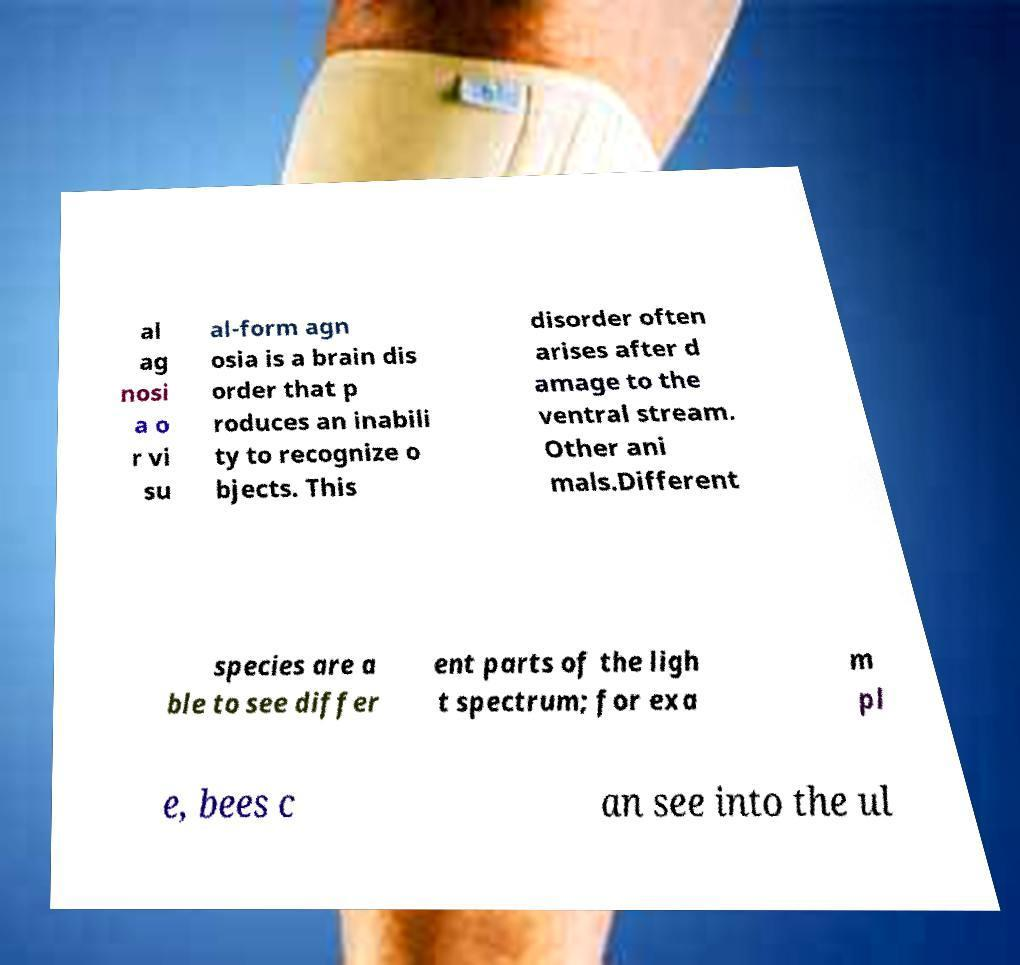Can you accurately transcribe the text from the provided image for me? al ag nosi a o r vi su al-form agn osia is a brain dis order that p roduces an inabili ty to recognize o bjects. This disorder often arises after d amage to the ventral stream. Other ani mals.Different species are a ble to see differ ent parts of the ligh t spectrum; for exa m pl e, bees c an see into the ul 